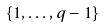<formula> <loc_0><loc_0><loc_500><loc_500>\{ 1 , \dots , q - 1 \}</formula> 